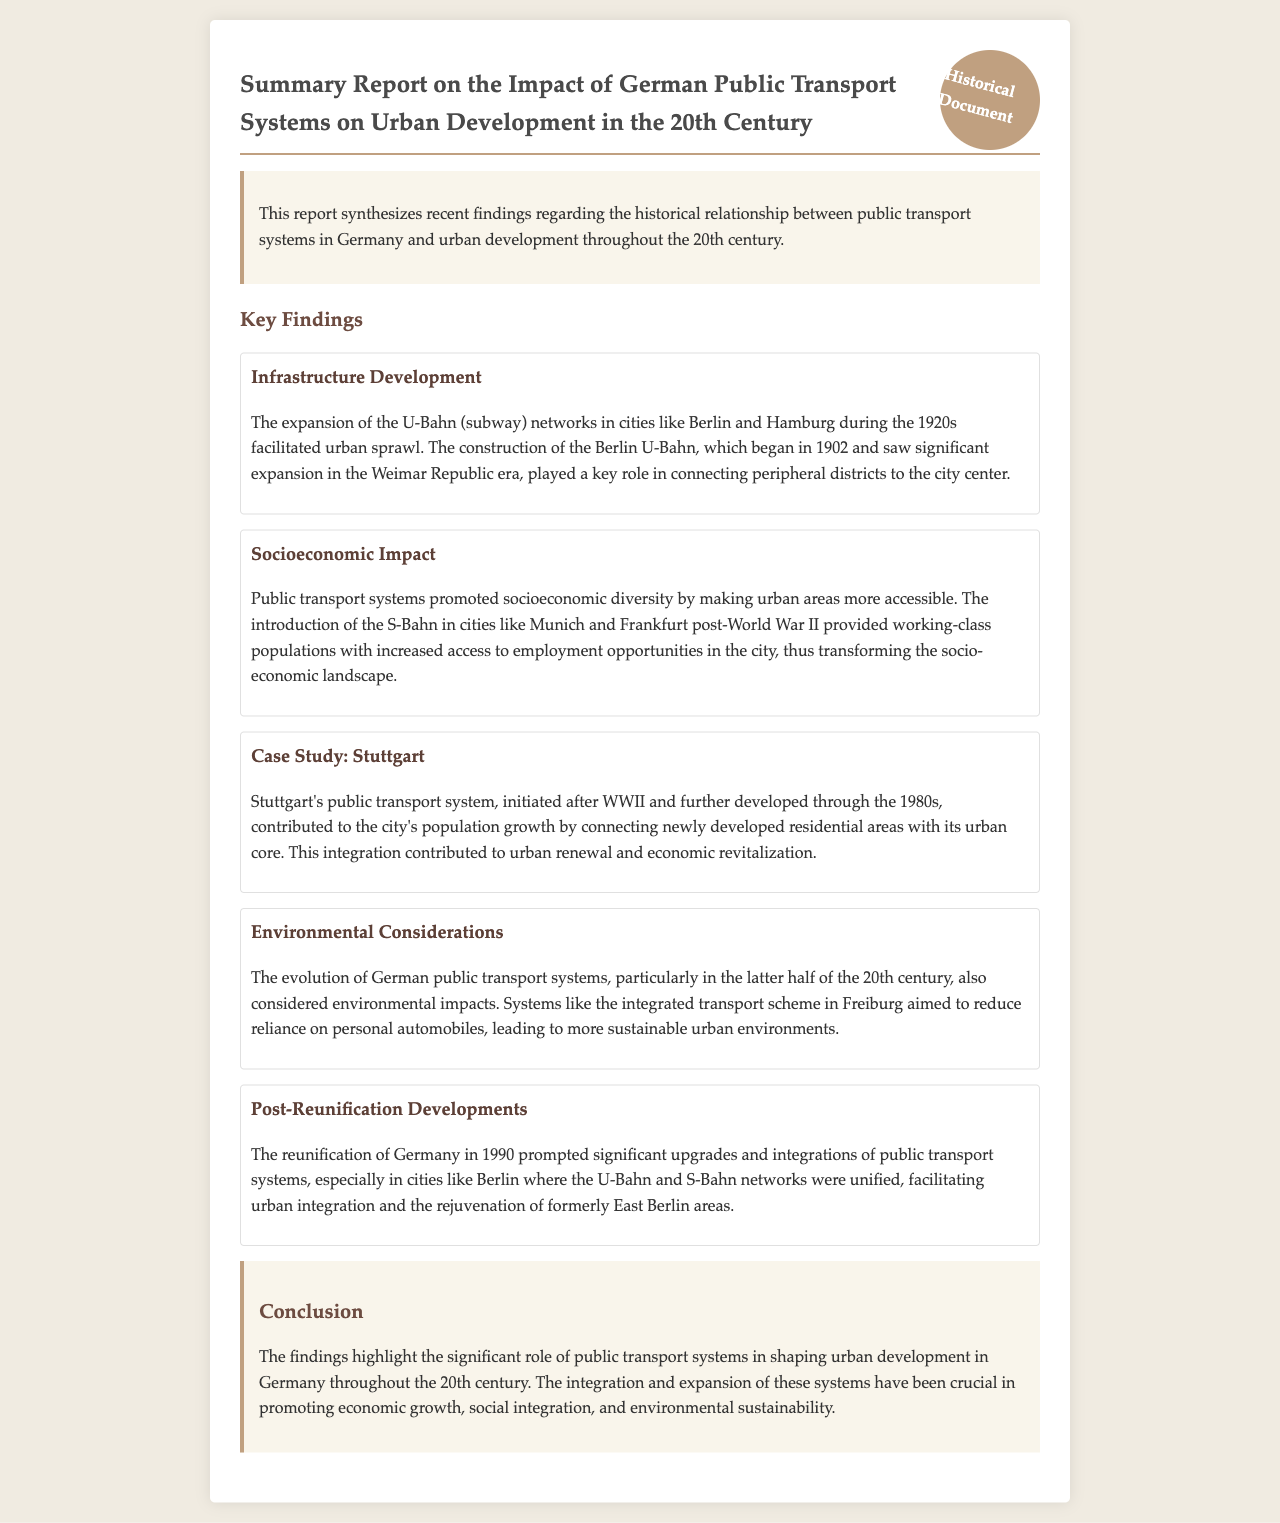What was the key role of the Berlin U-Bahn? The Berlin U-Bahn played a key role in connecting peripheral districts to the city center.
Answer: connecting peripheral districts to the city center What city began significant U-Bahn expansion in the 1920s? The document specifies that Berlin is the city where significant U-Bahn expansion occurred in the 1920s.
Answer: Berlin What new public transport introduced increased access to employment? The introduction of the S-Bahn provided working-class populations with increased access to employment opportunities.
Answer: S-Bahn Which city's public transport system was developed after WWII? The document notes that Stuttgart's public transport system was initiated after WWII.
Answer: Stuttgart What decade saw the evolution of integrated transport schemes in Freiburg? The evolution of integrated transport schemes, particularly in Freiburg, was noted in the latter half of the 20th century.
Answer: latter half of the 20th century What year marked the reunification of Germany, prompting transport developments? The document states that the reunification of Germany occurred in 1990.
Answer: 1990 Which city's U-Bahn and S-Bahn networks were unified post-reunification? The document mentions that Berlin's U-Bahn and S-Bahn networks were unified after the reunification.
Answer: Berlin What was one impact of public transport systems on urban environments? The systems aimed to reduce reliance on personal automobiles, contributing to more sustainable urban environments.
Answer: reduce reliance on personal automobiles What demographic change was facilitated by public transport systems according to the report? Public transport systems promoted socioeconomic diversity by making urban areas more accessible.
Answer: socioeconomic diversity 